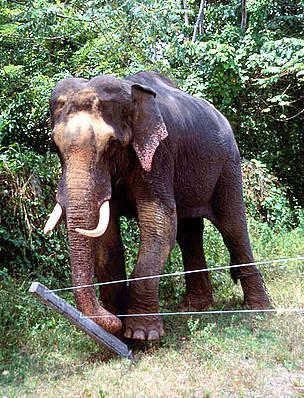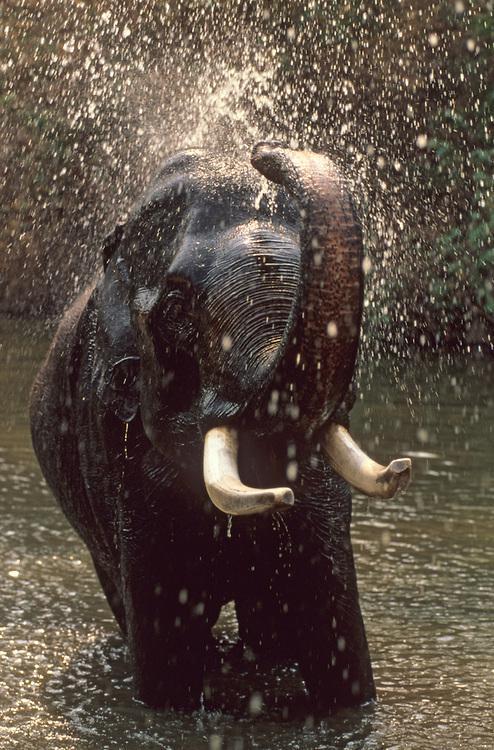The first image is the image on the left, the second image is the image on the right. For the images shown, is this caption "A leftward-facing elephant has a type of chair strapped to its back." true? Answer yes or no. No. The first image is the image on the left, the second image is the image on the right. Assess this claim about the two images: "A person is riding an elephant that is wading through water.". Correct or not? Answer yes or no. No. 